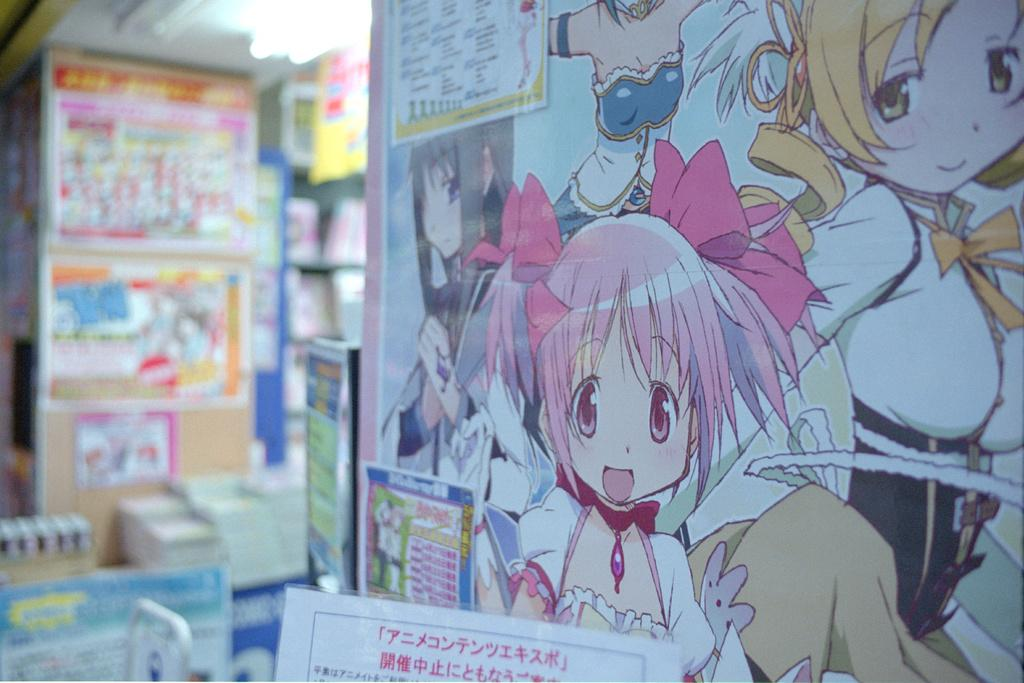What is shown on the wall in the image? There is a depiction of persons on the wall in the image. What is located at the bottom of the image? There is a placard at the bottom of the image. How would you describe the background of the image? The background of the image is blurred. Can you see the grandmother running through the airport in the image? There is no grandmother or airport present in the image. 